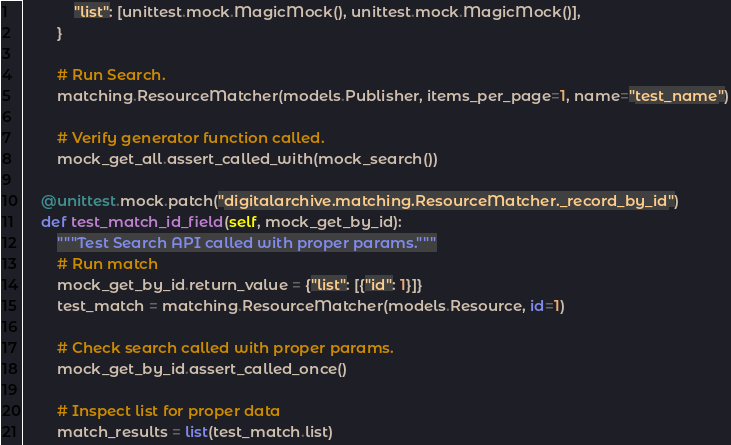Convert code to text. <code><loc_0><loc_0><loc_500><loc_500><_Python_>            "list": [unittest.mock.MagicMock(), unittest.mock.MagicMock()],
        }

        # Run Search.
        matching.ResourceMatcher(models.Publisher, items_per_page=1, name="test_name")

        # Verify generator function called.
        mock_get_all.assert_called_with(mock_search())

    @unittest.mock.patch("digitalarchive.matching.ResourceMatcher._record_by_id")
    def test_match_id_field(self, mock_get_by_id):
        """Test Search API called with proper params."""
        # Run match
        mock_get_by_id.return_value = {"list": [{"id": 1}]}
        test_match = matching.ResourceMatcher(models.Resource, id=1)

        # Check search called with proper params.
        mock_get_by_id.assert_called_once()

        # Inspect list for proper data
        match_results = list(test_match.list)</code> 